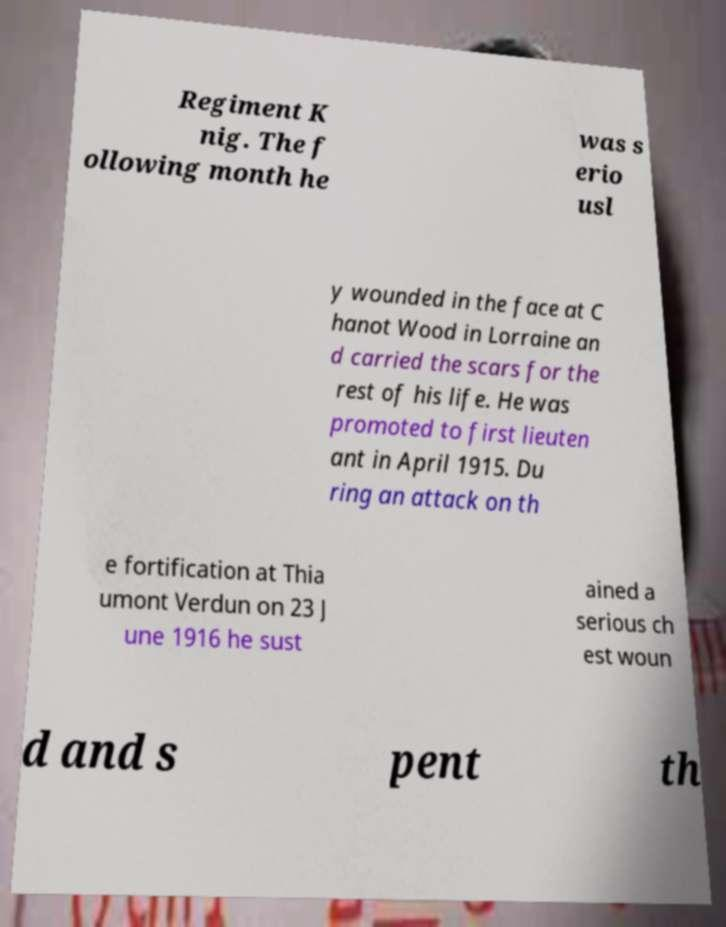Please read and relay the text visible in this image. What does it say? Regiment K nig. The f ollowing month he was s erio usl y wounded in the face at C hanot Wood in Lorraine an d carried the scars for the rest of his life. He was promoted to first lieuten ant in April 1915. Du ring an attack on th e fortification at Thia umont Verdun on 23 J une 1916 he sust ained a serious ch est woun d and s pent th 